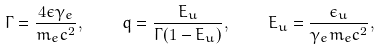Convert formula to latex. <formula><loc_0><loc_0><loc_500><loc_500>\Gamma = \frac { 4 \epsilon \gamma _ { e } } { m _ { e } c ^ { 2 } } , \quad q = \frac { E _ { u } } { \Gamma ( 1 - E _ { u } ) } , \quad E _ { u } = \frac { \epsilon _ { u } } { \gamma _ { e } m _ { e } c ^ { 2 } } ,</formula> 